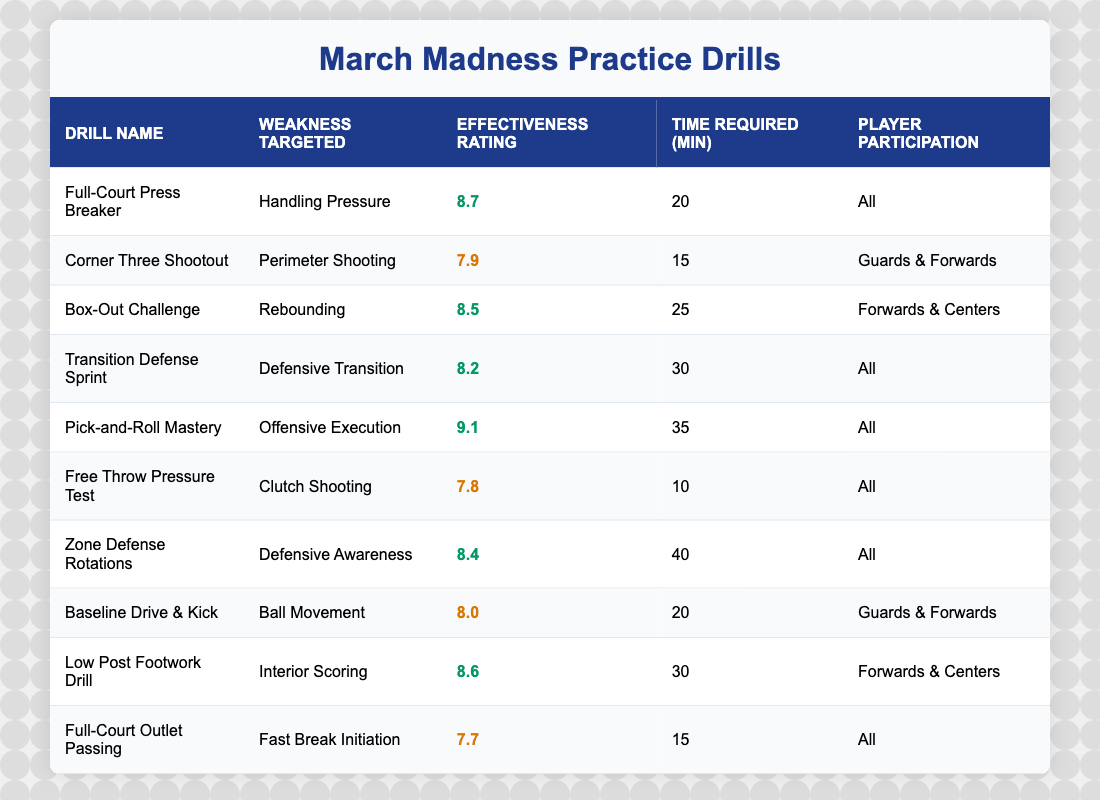What is the effectiveness rating of the Zone Defense Rotations drill? The effectiveness rating of the Zone Defense Rotations drill can be found in the third column of its corresponding row. It is listed as 8.4.
Answer: 8.4 Which drill has the highest effectiveness rating? By scanning through the effectiveness ratings in the table, the highest rating is 9.1, which corresponds to the Pick-and-Roll Mastery drill.
Answer: 9.1 How many minutes does the Corner Three Shootout drill require? The time required for the Corner Three Shootout drill is noted in the fourth column. It states that it requires 15 minutes.
Answer: 15 minutes Is the effectiveness rating of the Full-Court Press Breaker greater than 8.0? The effectiveness rating of the Full-Court Press Breaker is listed as 8.7. Since 8.7 is greater than 8.0, the statement is true.
Answer: Yes What is the average effectiveness rating of all drills? To find the average effectiveness rating, first sum all the ratings: (8.7 + 7.9 + 8.5 + 8.2 + 9.1 + 7.8 + 8.4 + 8.0 + 8.6 + 7.7) = 8.34. Since there are 10 drills, the average is 83.4/10 = 8.34.
Answer: 8.34 